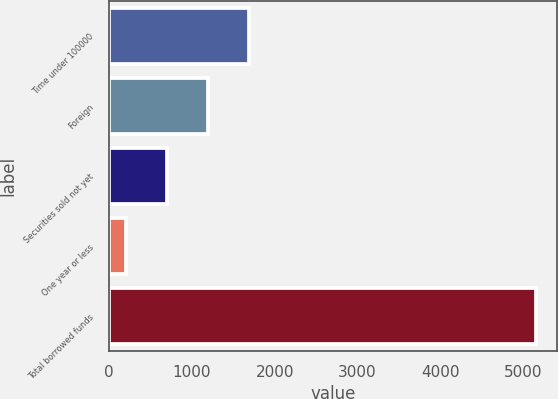Convert chart. <chart><loc_0><loc_0><loc_500><loc_500><bar_chart><fcel>Time under 100000<fcel>Foreign<fcel>Securities sold not yet<fcel>One year or less<fcel>Total borrowed funds<nl><fcel>1687.5<fcel>1193<fcel>698.5<fcel>204<fcel>5149<nl></chart> 